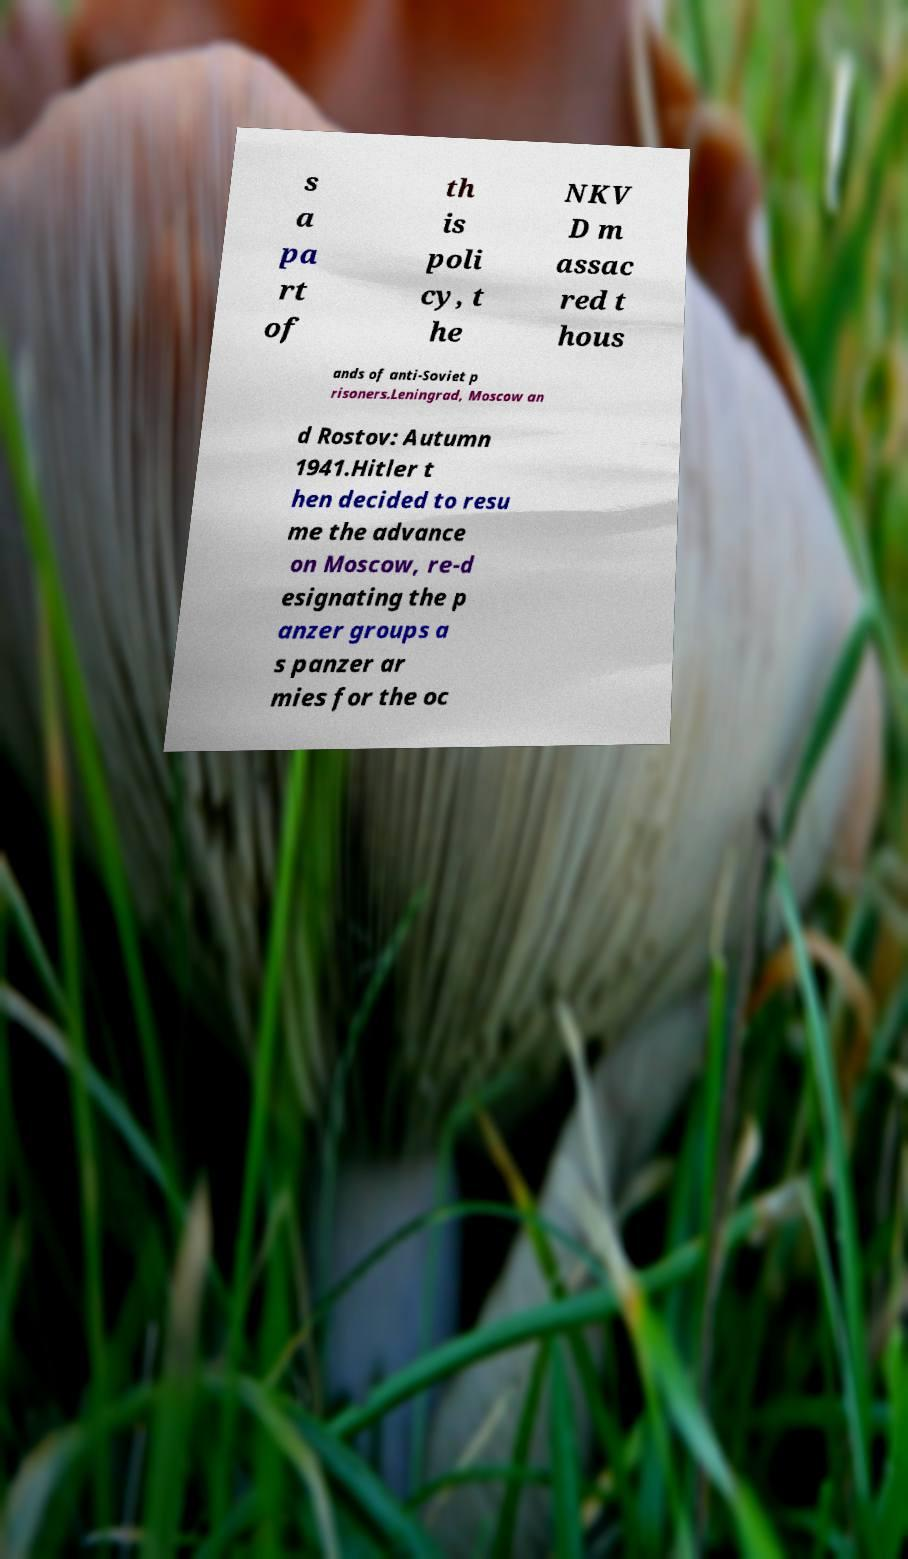Could you extract and type out the text from this image? s a pa rt of th is poli cy, t he NKV D m assac red t hous ands of anti-Soviet p risoners.Leningrad, Moscow an d Rostov: Autumn 1941.Hitler t hen decided to resu me the advance on Moscow, re-d esignating the p anzer groups a s panzer ar mies for the oc 